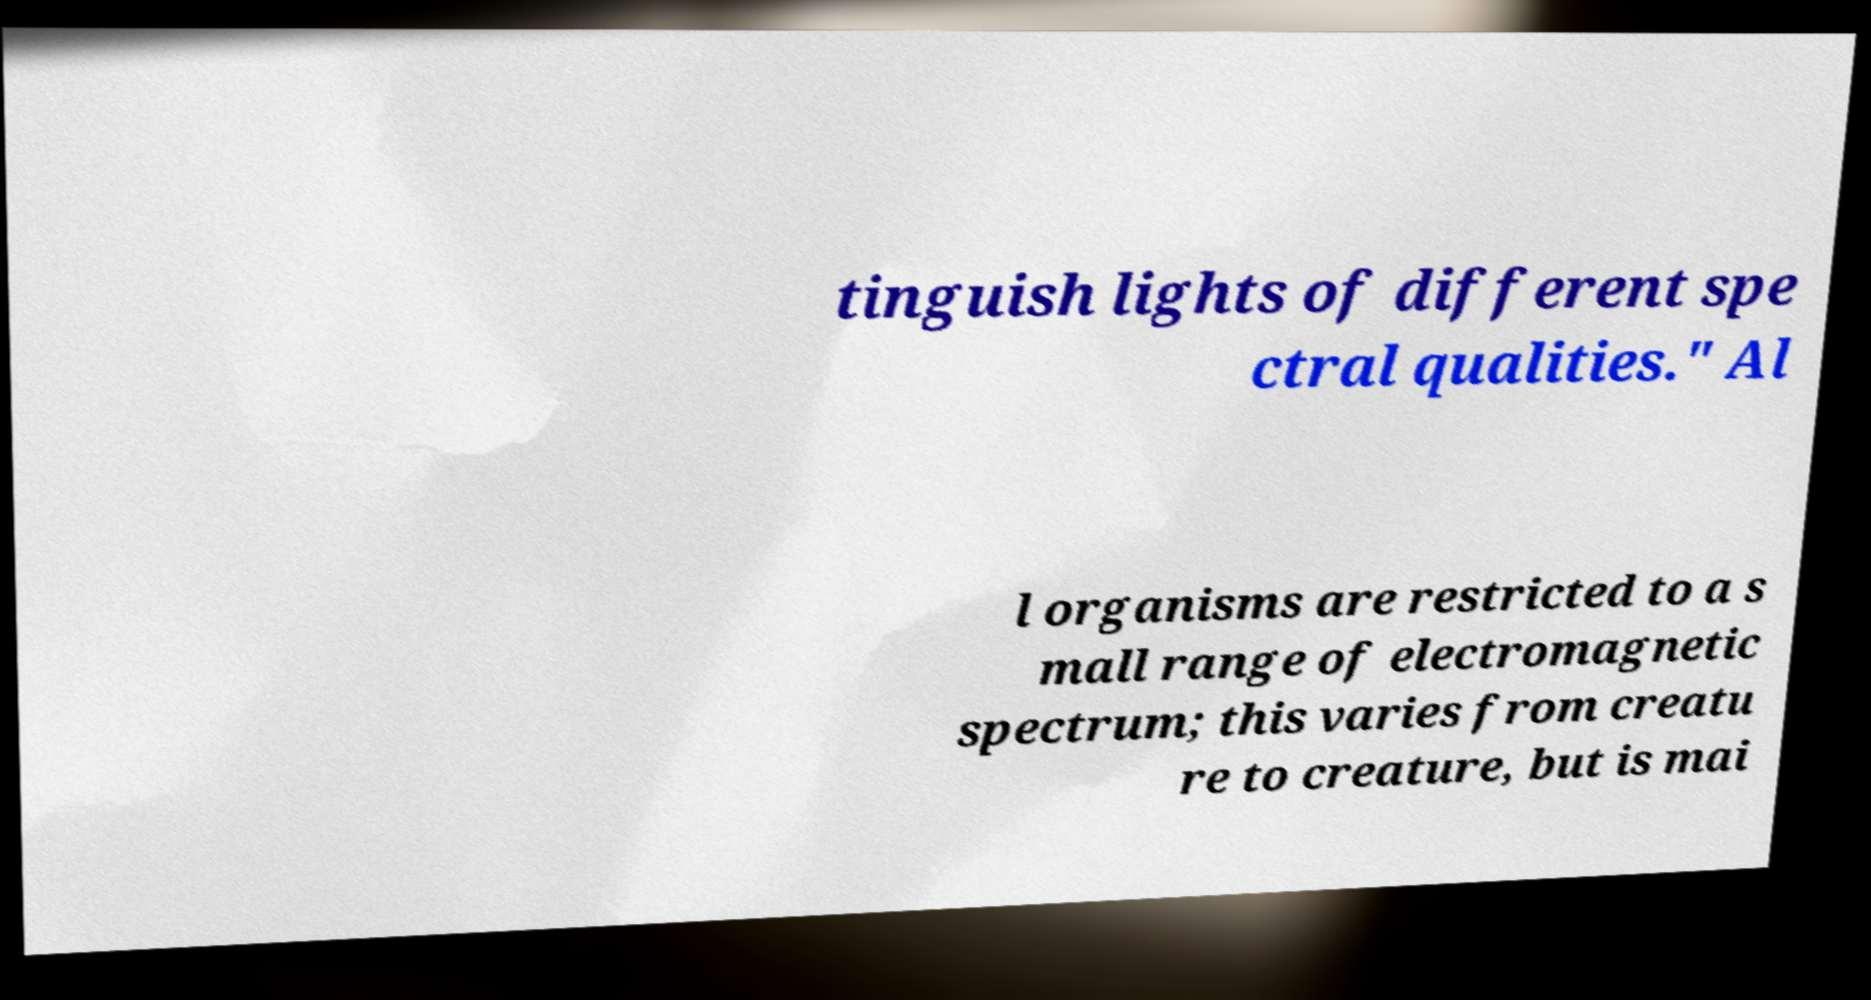Please read and relay the text visible in this image. What does it say? tinguish lights of different spe ctral qualities." Al l organisms are restricted to a s mall range of electromagnetic spectrum; this varies from creatu re to creature, but is mai 